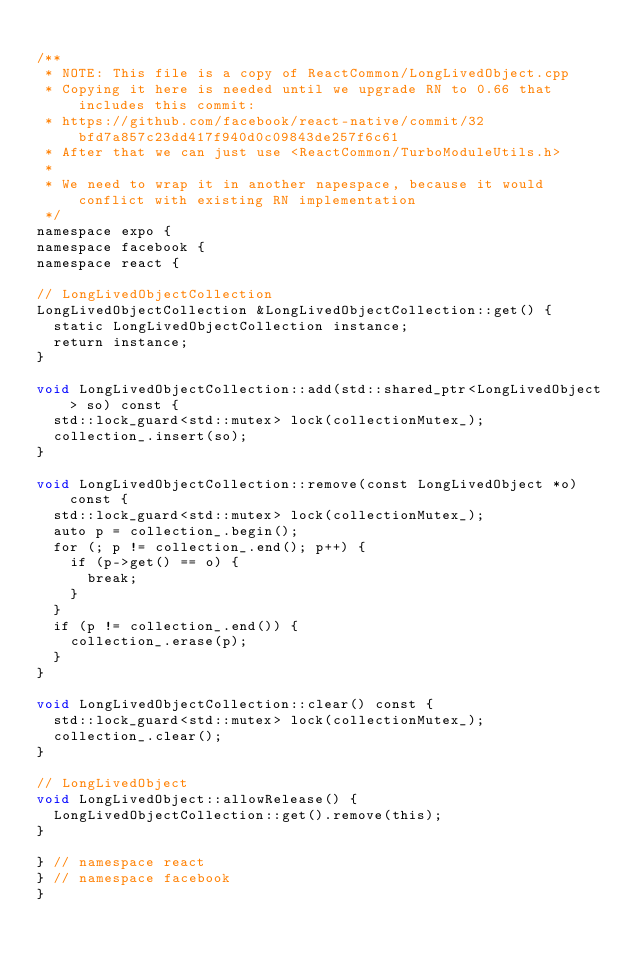Convert code to text. <code><loc_0><loc_0><loc_500><loc_500><_ObjectiveC_>
/**
 * NOTE: This file is a copy of ReactCommon/LongLivedObject.cpp
 * Copying it here is needed until we upgrade RN to 0.66 that includes this commit:
 * https://github.com/facebook/react-native/commit/32bfd7a857c23dd417f940d0c09843de257f6c61
 * After that we can just use <ReactCommon/TurboModuleUtils.h>
 *
 * We need to wrap it in another napespace, because it would conflict with existing RN implementation
 */
namespace expo {
namespace facebook {
namespace react {

// LongLivedObjectCollection
LongLivedObjectCollection &LongLivedObjectCollection::get() {
  static LongLivedObjectCollection instance;
  return instance;
}

void LongLivedObjectCollection::add(std::shared_ptr<LongLivedObject> so) const {
  std::lock_guard<std::mutex> lock(collectionMutex_);
  collection_.insert(so);
}

void LongLivedObjectCollection::remove(const LongLivedObject *o) const {
  std::lock_guard<std::mutex> lock(collectionMutex_);
  auto p = collection_.begin();
  for (; p != collection_.end(); p++) {
    if (p->get() == o) {
      break;
    }
  }
  if (p != collection_.end()) {
    collection_.erase(p);
  }
}

void LongLivedObjectCollection::clear() const {
  std::lock_guard<std::mutex> lock(collectionMutex_);
  collection_.clear();
}

// LongLivedObject
void LongLivedObject::allowRelease() {
  LongLivedObjectCollection::get().remove(this);
}

} // namespace react
} // namespace facebook
}

</code> 